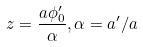<formula> <loc_0><loc_0><loc_500><loc_500>z = \frac { a \phi _ { 0 } ^ { \prime } } { \alpha } , \alpha = a ^ { \prime } / a</formula> 